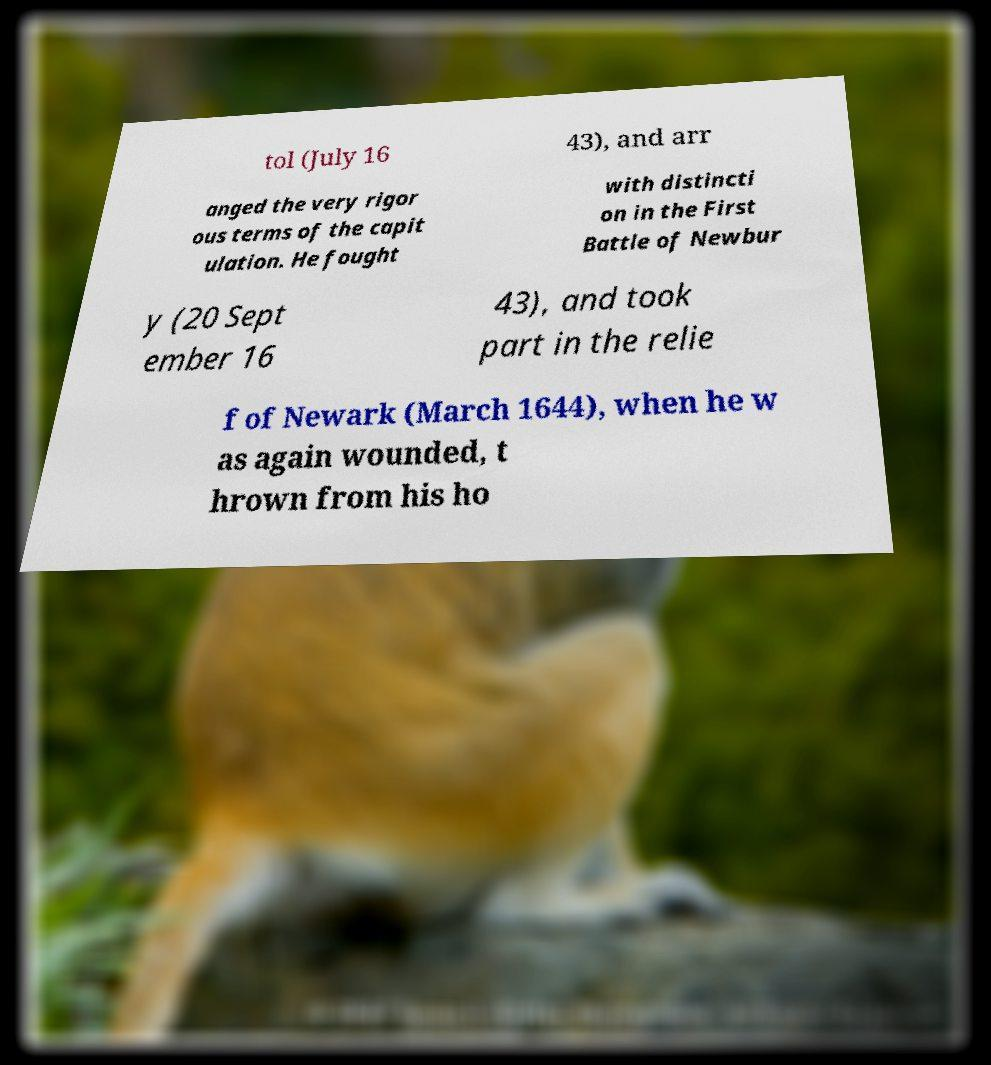For documentation purposes, I need the text within this image transcribed. Could you provide that? tol (July 16 43), and arr anged the very rigor ous terms of the capit ulation. He fought with distincti on in the First Battle of Newbur y (20 Sept ember 16 43), and took part in the relie f of Newark (March 1644), when he w as again wounded, t hrown from his ho 